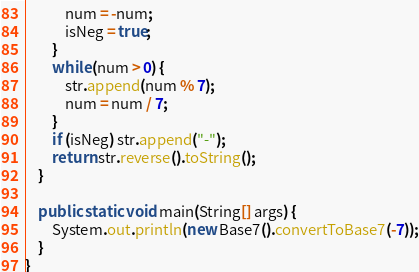Convert code to text. <code><loc_0><loc_0><loc_500><loc_500><_Java_>            num = -num;
            isNeg = true;
        }
        while (num > 0) {
            str.append(num % 7);
            num = num / 7;
        }
        if (isNeg) str.append("-");
        return str.reverse().toString();
    }

    public static void main(String[] args) {
        System.out.println(new Base7().convertToBase7(-7));
    }
}
</code> 